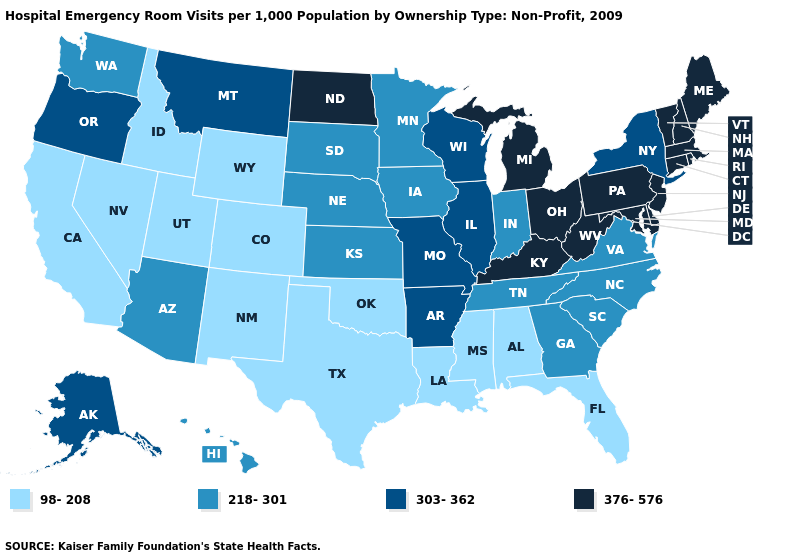How many symbols are there in the legend?
Answer briefly. 4. What is the value of Arizona?
Write a very short answer. 218-301. Does Indiana have a higher value than Pennsylvania?
Keep it brief. No. How many symbols are there in the legend?
Short answer required. 4. Name the states that have a value in the range 98-208?
Keep it brief. Alabama, California, Colorado, Florida, Idaho, Louisiana, Mississippi, Nevada, New Mexico, Oklahoma, Texas, Utah, Wyoming. Among the states that border Nebraska , which have the lowest value?
Quick response, please. Colorado, Wyoming. Name the states that have a value in the range 218-301?
Answer briefly. Arizona, Georgia, Hawaii, Indiana, Iowa, Kansas, Minnesota, Nebraska, North Carolina, South Carolina, South Dakota, Tennessee, Virginia, Washington. What is the value of North Dakota?
Concise answer only. 376-576. What is the value of Vermont?
Short answer required. 376-576. What is the value of Kansas?
Quick response, please. 218-301. Which states have the highest value in the USA?
Keep it brief. Connecticut, Delaware, Kentucky, Maine, Maryland, Massachusetts, Michigan, New Hampshire, New Jersey, North Dakota, Ohio, Pennsylvania, Rhode Island, Vermont, West Virginia. Does Hawaii have the highest value in the USA?
Answer briefly. No. Among the states that border Mississippi , which have the lowest value?
Quick response, please. Alabama, Louisiana. Name the states that have a value in the range 218-301?
Answer briefly. Arizona, Georgia, Hawaii, Indiana, Iowa, Kansas, Minnesota, Nebraska, North Carolina, South Carolina, South Dakota, Tennessee, Virginia, Washington. 